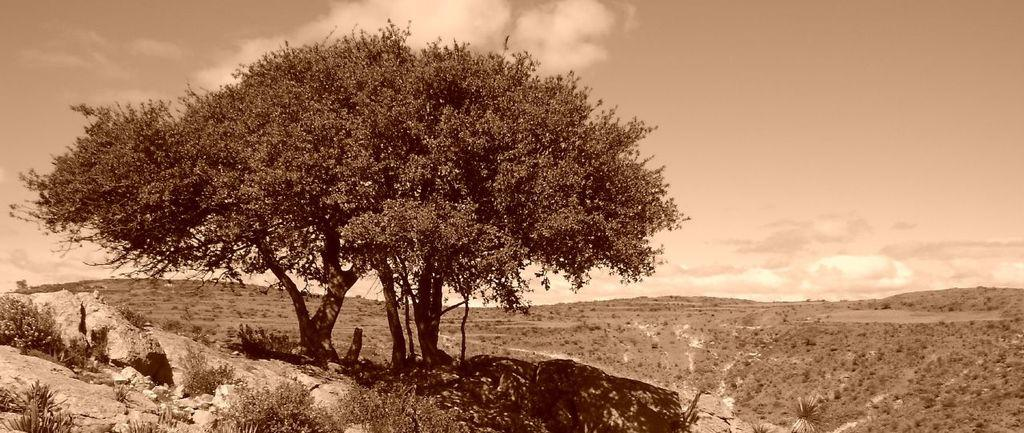What is the main subject in the middle of the image? There is a tree in the middle of the image. What type of vegetation is present at the bottom of the image? There are bushes at the bottom of the image. What is visible at the top of the image? The sky is visible at the top of the image. What type of tub can be seen in the image? There is no tub present in the image. What discovery was made near the tree in the image? There is no mention of a discovery in the image; it simply features a tree, bushes, and the sky. 